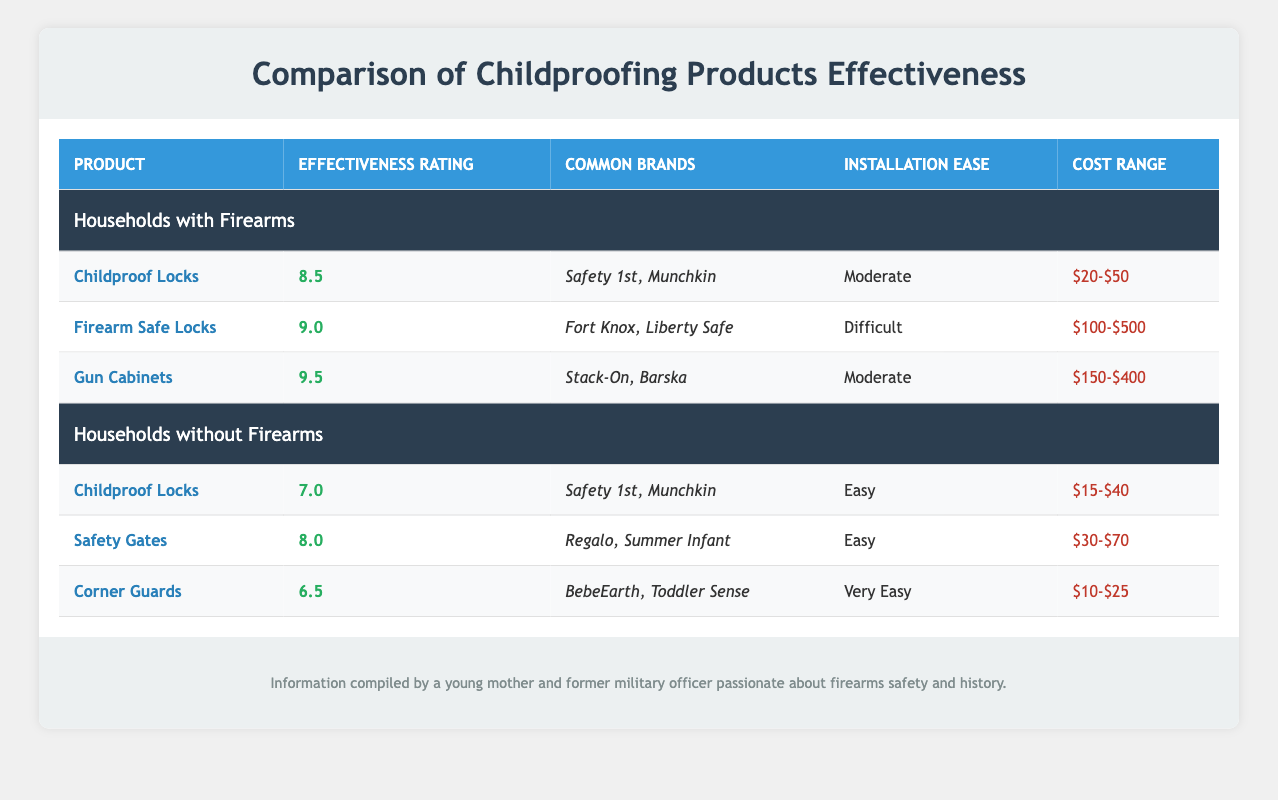What is the effectiveness rating of Gun Cabinets in households with firearms? The effectiveness rating for Gun Cabinets is listed as 9.5 in the table under Households with Firearms.
Answer: 9.5 What are the common brands for Childproof Locks in households without firearms? The table shows that the common brands for Childproof Locks in households without firearms include Safety 1st and Munchkin.
Answer: Safety 1st, Munchkin Are Firearm Safe Locks easier to install than Safety Gates? Firearm Safe Locks have an installation ease rating of "Difficult," while Safety Gates are rated as "Easy." Thus, Firearm Safe Locks are not easier to install than Safety Gates.
Answer: No Which product has the highest effectiveness rating in households with firearms? According to the table, Gun Cabinets have the highest effectiveness rating of 9.5 among the products listed for households with firearms.
Answer: Gun Cabinets What is the average effectiveness rating of the childproofing products in households without firearms? The effectiveness ratings for products in households without firearms are 7.0 (Childproof Locks), 8.0 (Safety Gates), and 6.5 (Corner Guards). The average is calculated by summing these ratings (7.0 + 8.0 + 6.5 = 21.5) and dividing by the number of products (3), giving 21.5/3 = 7.17.
Answer: 7.17 Is the cost range for Childproof Locks higher in households with firearms compared to those without? The cost range for Childproof Locks in households with firearms is $20-$50, while in households without firearms, it is $15-$40. Since $20 is greater than $15, the cost range for Childproof Locks is higher in households with firearms.
Answer: Yes What product in households without firearms has the lowest effectiveness rating? The effectiveness ratings for households without firearms are 7.0 (Childproof Locks), 8.0 (Safety Gates), and 6.5 (Corner Guards). The lowest effectiveness rating is 6.5 for Corner Guards.
Answer: Corner Guards How much more expensive is the average cost of Gun Cabinets compared to Childproof Locks in households with firearms? The cost range for Gun Cabinets is $150-$400 and for Childproof Locks is $20-$50. To find the average cost for both, we take the midpoint. For Gun Cabinets, the average is (150 + 400) / 2 = 275, and for Childproof Locks, it is (20 + 50) / 2 = 35. The difference is 275 - 35 = 240.
Answer: $240 Which product has a lower effectiveness rating, Corner Guards or Childproof Locks in households with firearms? In the table, the effectiveness rating for Childproof Locks in households with firearms is 8.5 and for Corner Guards in households without firearms is 6.5. Since 6.5 is lower than 8.5, Corner Guards have a lower effectiveness rating.
Answer: Corner Guards 